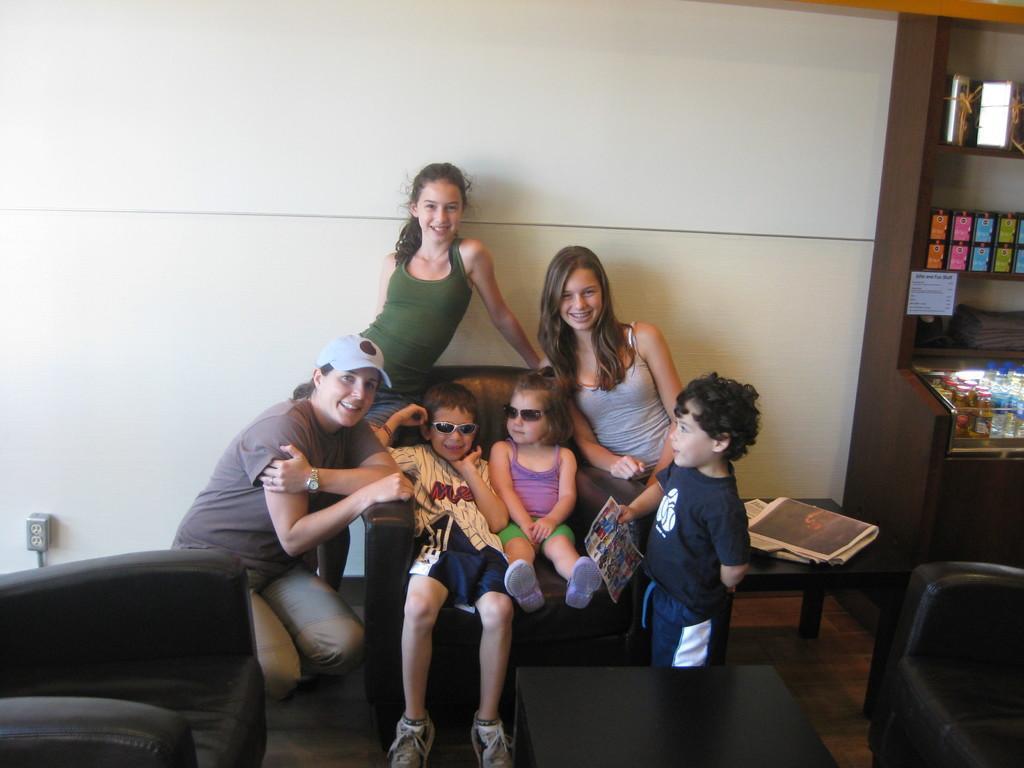In one or two sentences, can you explain what this image depicts? This 2 kids are sitting on a black couch. This persons are beside the couch. On a table there is a news papers. This is a rack with a number of things. This kid is holding a paper. This woman wore cap. 